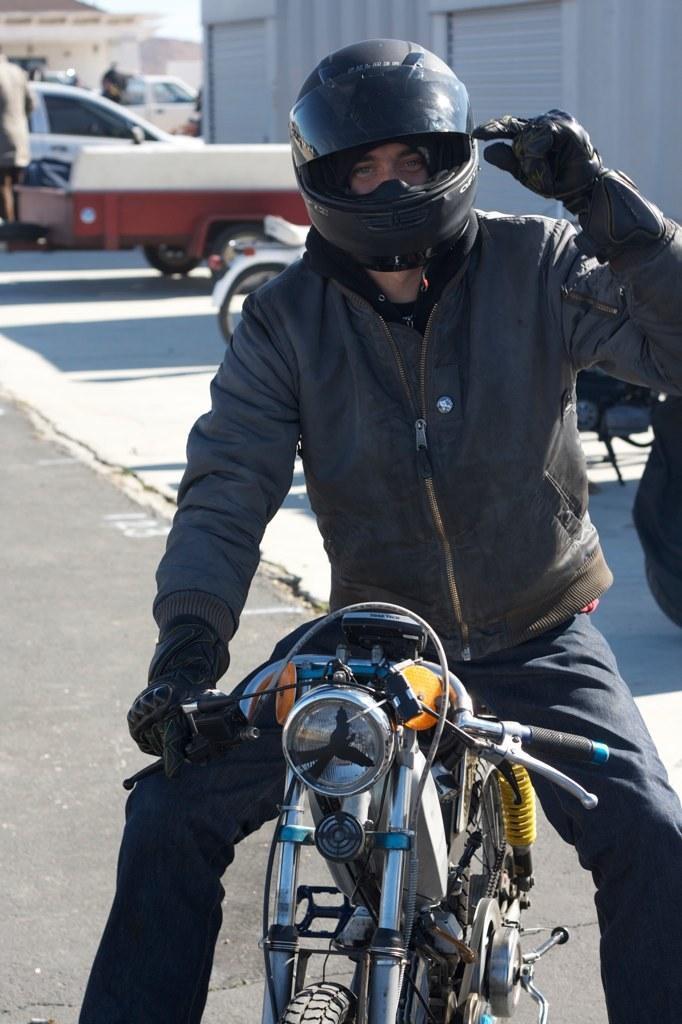Can you describe this image briefly? In this image on the right side there is one motor bike and on that motor bike there is one person who is sitting and he is wearing helmet and gloves and on the background there are vehicles. 